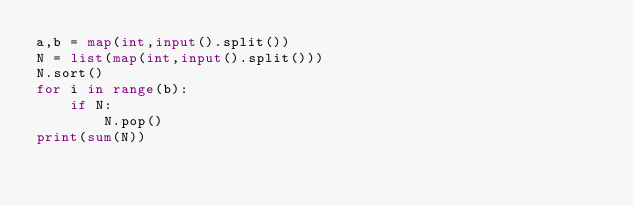Convert code to text. <code><loc_0><loc_0><loc_500><loc_500><_Python_>a,b = map(int,input().split())
N = list(map(int,input().split()))
N.sort()
for i in range(b):
    if N:
        N.pop()
print(sum(N))</code> 